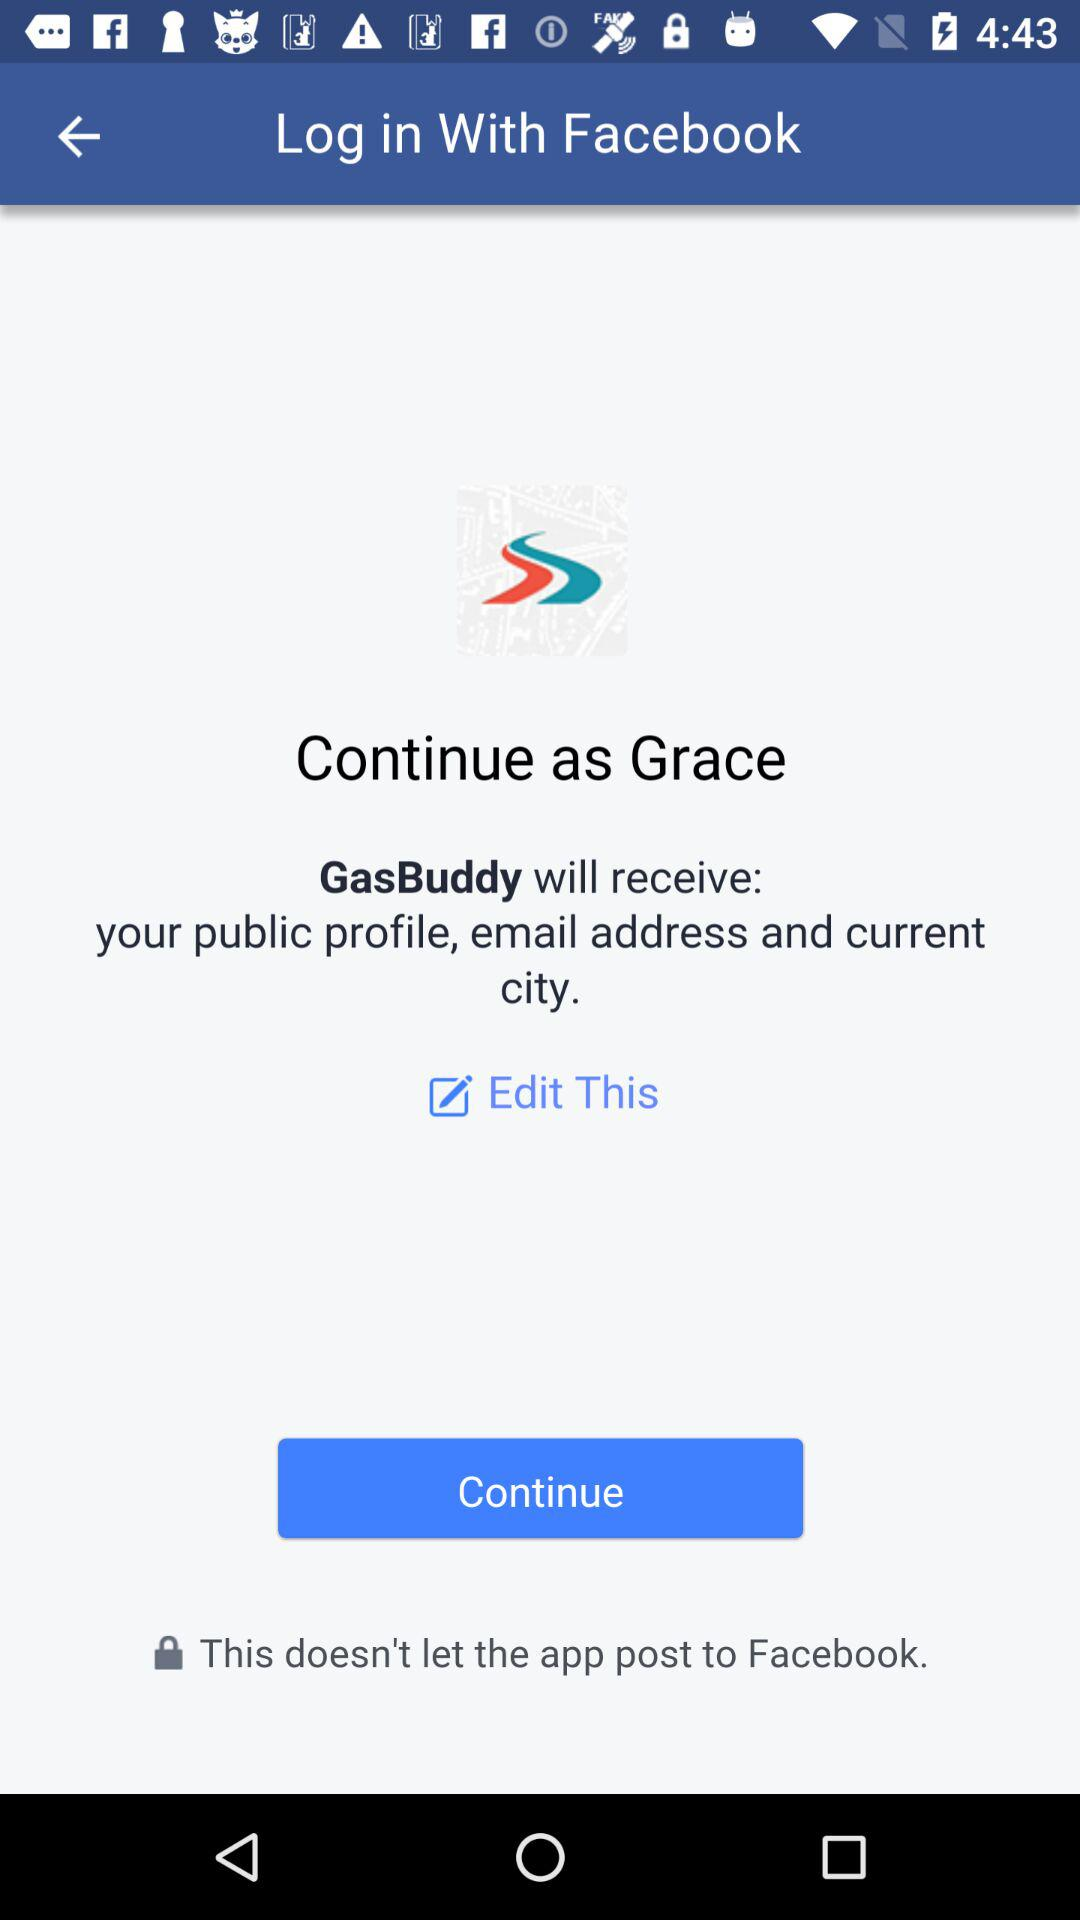What application is asking for permission? The application that is asking for permission is "Facebook". 